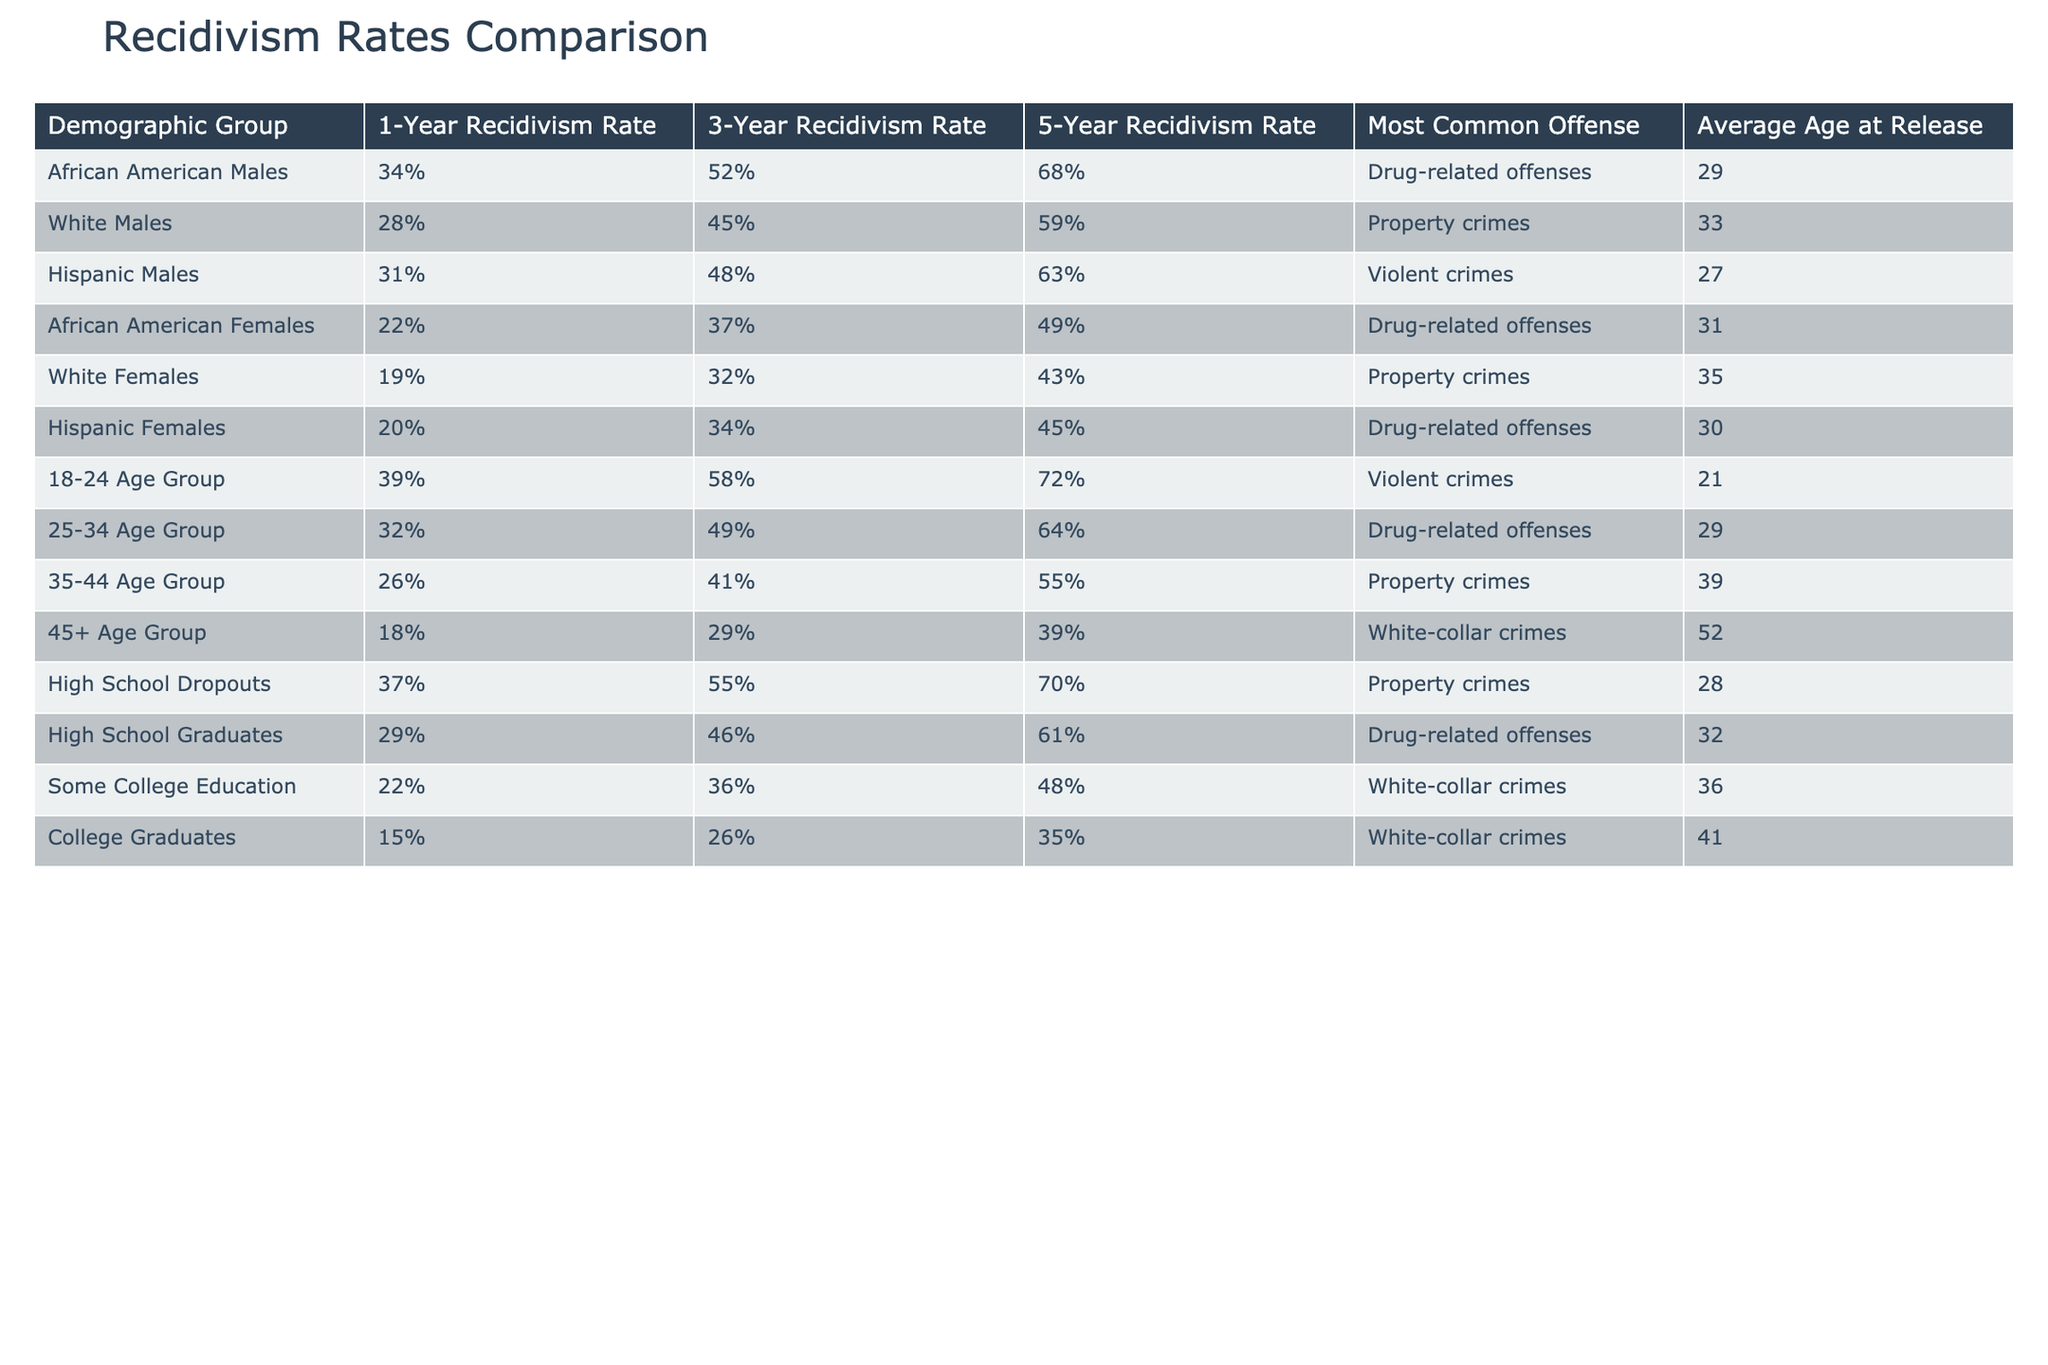What is the recidivism rate for African American Females after 3 years? The table indicates that the 3-Year Recidivism Rate for African American Females is 37%.
Answer: 37% Which demographic group has the highest 1-Year Recidivism Rate? From the table, the demographic group with the highest 1-Year Recidivism Rate is the 18-24 Age Group at 39%.
Answer: 39% Is the 5-Year Recidivism Rate for High School Graduates lower than that of Hispanic Males? Checking the table, High School Graduates have a 5-Year Recidivism Rate of 43%, while Hispanic Males have a 5-Year Recidivism Rate of 63%, which means that High School Graduates have a lower rate.
Answer: Yes What is the average 3-Year Recidivism Rate for all males listed in the table? The 3-Year Recidivism Rates for males are: African American Males (52%), White Males (45%), Hispanic Males (48%), 18-24 Age Group (58%), 25-34 Age Group (49%), High School Dropouts (55%). Summing them up gives 52 + 45 + 48 + 58 + 49 + 55 = 307. Dividing by 6 (the number of groups) gives an average of 51.17.
Answer: 51.17 Which group has the lowest recidivism rates across all timeframes? Looking at the table, the group 45+ Age Group has the lowest recidivism rates: 18% (1-Year), 29% (3-Year), 39% (5-Year). All these rates are lower than any other groups.
Answer: 45+ Age Group How do the recidivism rates of College Graduates compare to High School Dropouts over 1, 3, and 5 years? College Graduates have rates of 15% (1-Year), 26% (3-Year), and 35% (5-Year). High School Dropouts have rates of 37% (1-Year), 55% (3-Year), and 70% (5-Year). Thus, College Graduates have significantly lower recidivism rates in all timeframes compared to High School Dropouts.
Answer: College Graduates have lower rates 